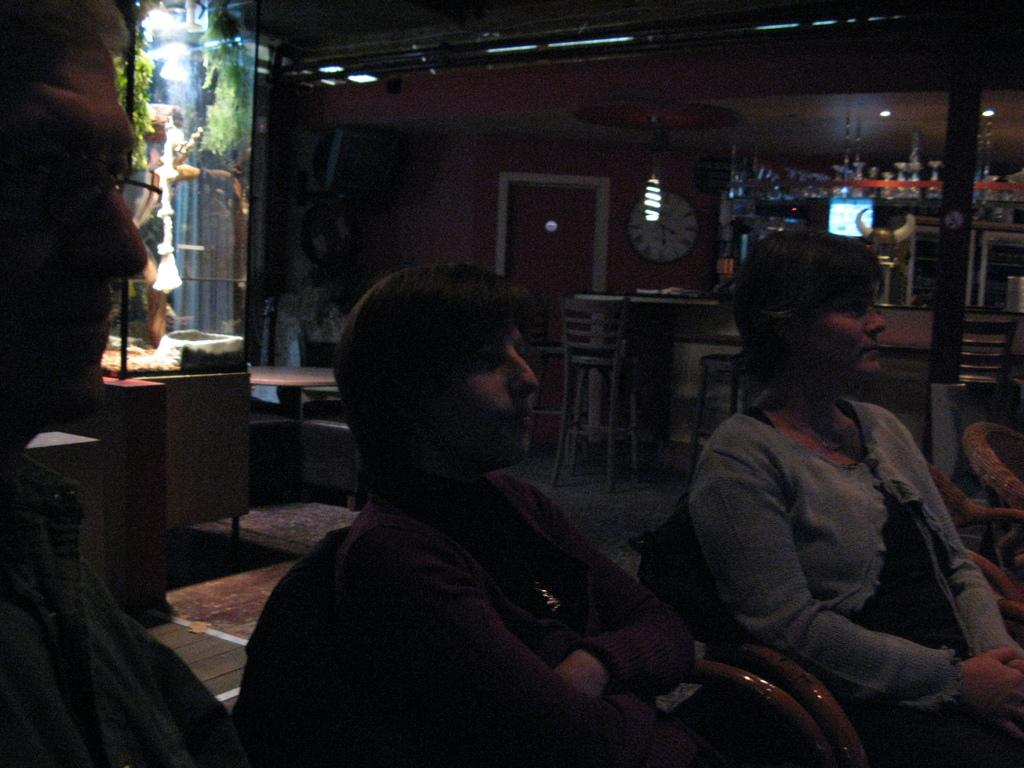What are the people in the image doing? The people in the front of the image are sitting on chairs. Can you describe the background of the image? In the background of the image, there are chairs, tables, a rack, a door, a television, a clock, lights, plants, a glass object, and other unspecified things. How many chairs are visible in the image? There are chairs in both the front and the background of the image, but the exact number is not specified. What type of quarter is being used to shape the drink in the image? There is no quarter or drink present in the image. What shape is the quarter taking in the image? There is no quarter present in the image, so it cannot be determined what shape it might be taking. 